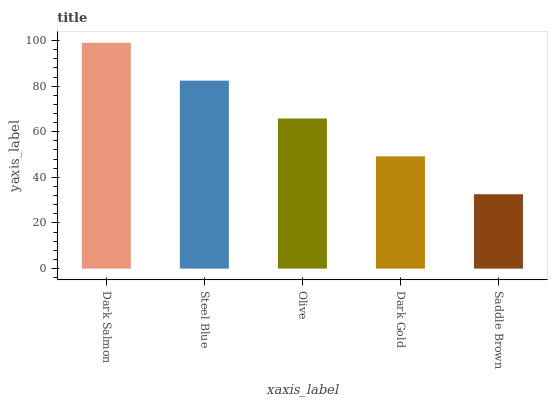Is Saddle Brown the minimum?
Answer yes or no. Yes. Is Dark Salmon the maximum?
Answer yes or no. Yes. Is Steel Blue the minimum?
Answer yes or no. No. Is Steel Blue the maximum?
Answer yes or no. No. Is Dark Salmon greater than Steel Blue?
Answer yes or no. Yes. Is Steel Blue less than Dark Salmon?
Answer yes or no. Yes. Is Steel Blue greater than Dark Salmon?
Answer yes or no. No. Is Dark Salmon less than Steel Blue?
Answer yes or no. No. Is Olive the high median?
Answer yes or no. Yes. Is Olive the low median?
Answer yes or no. Yes. Is Steel Blue the high median?
Answer yes or no. No. Is Steel Blue the low median?
Answer yes or no. No. 